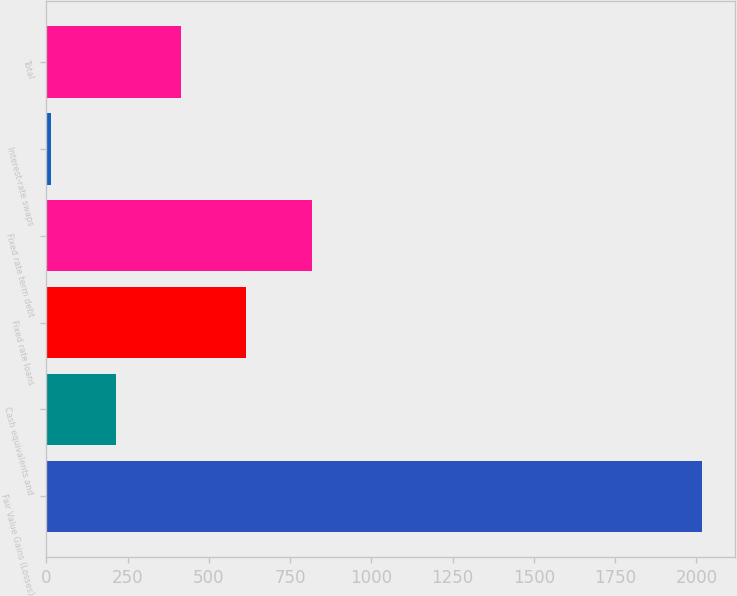<chart> <loc_0><loc_0><loc_500><loc_500><bar_chart><fcel>Fair Value Gains (Losses)<fcel>Cash equivalents and<fcel>Fixed rate loans<fcel>Fixed rate term debt<fcel>Interest-rate swaps<fcel>Total<nl><fcel>2017<fcel>215.2<fcel>615.6<fcel>815.8<fcel>15<fcel>415.4<nl></chart> 